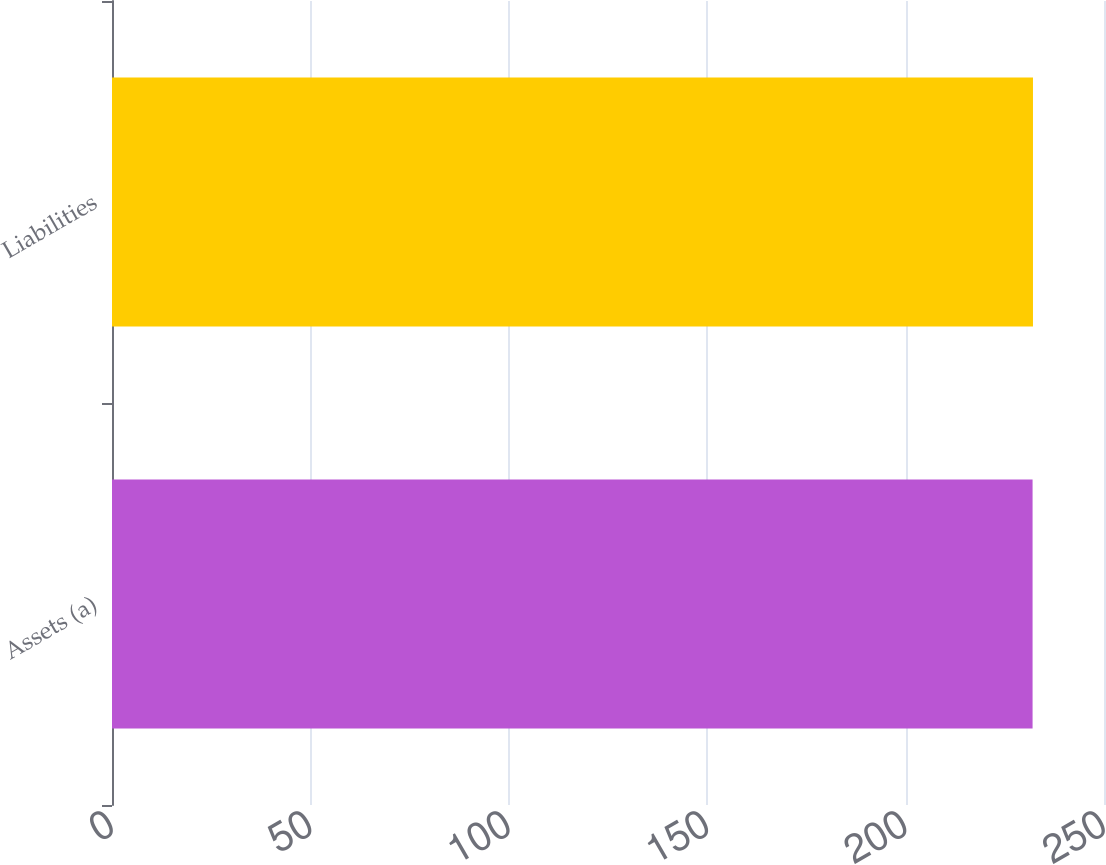<chart> <loc_0><loc_0><loc_500><loc_500><bar_chart><fcel>Assets (a)<fcel>Liabilities<nl><fcel>232<fcel>232.1<nl></chart> 